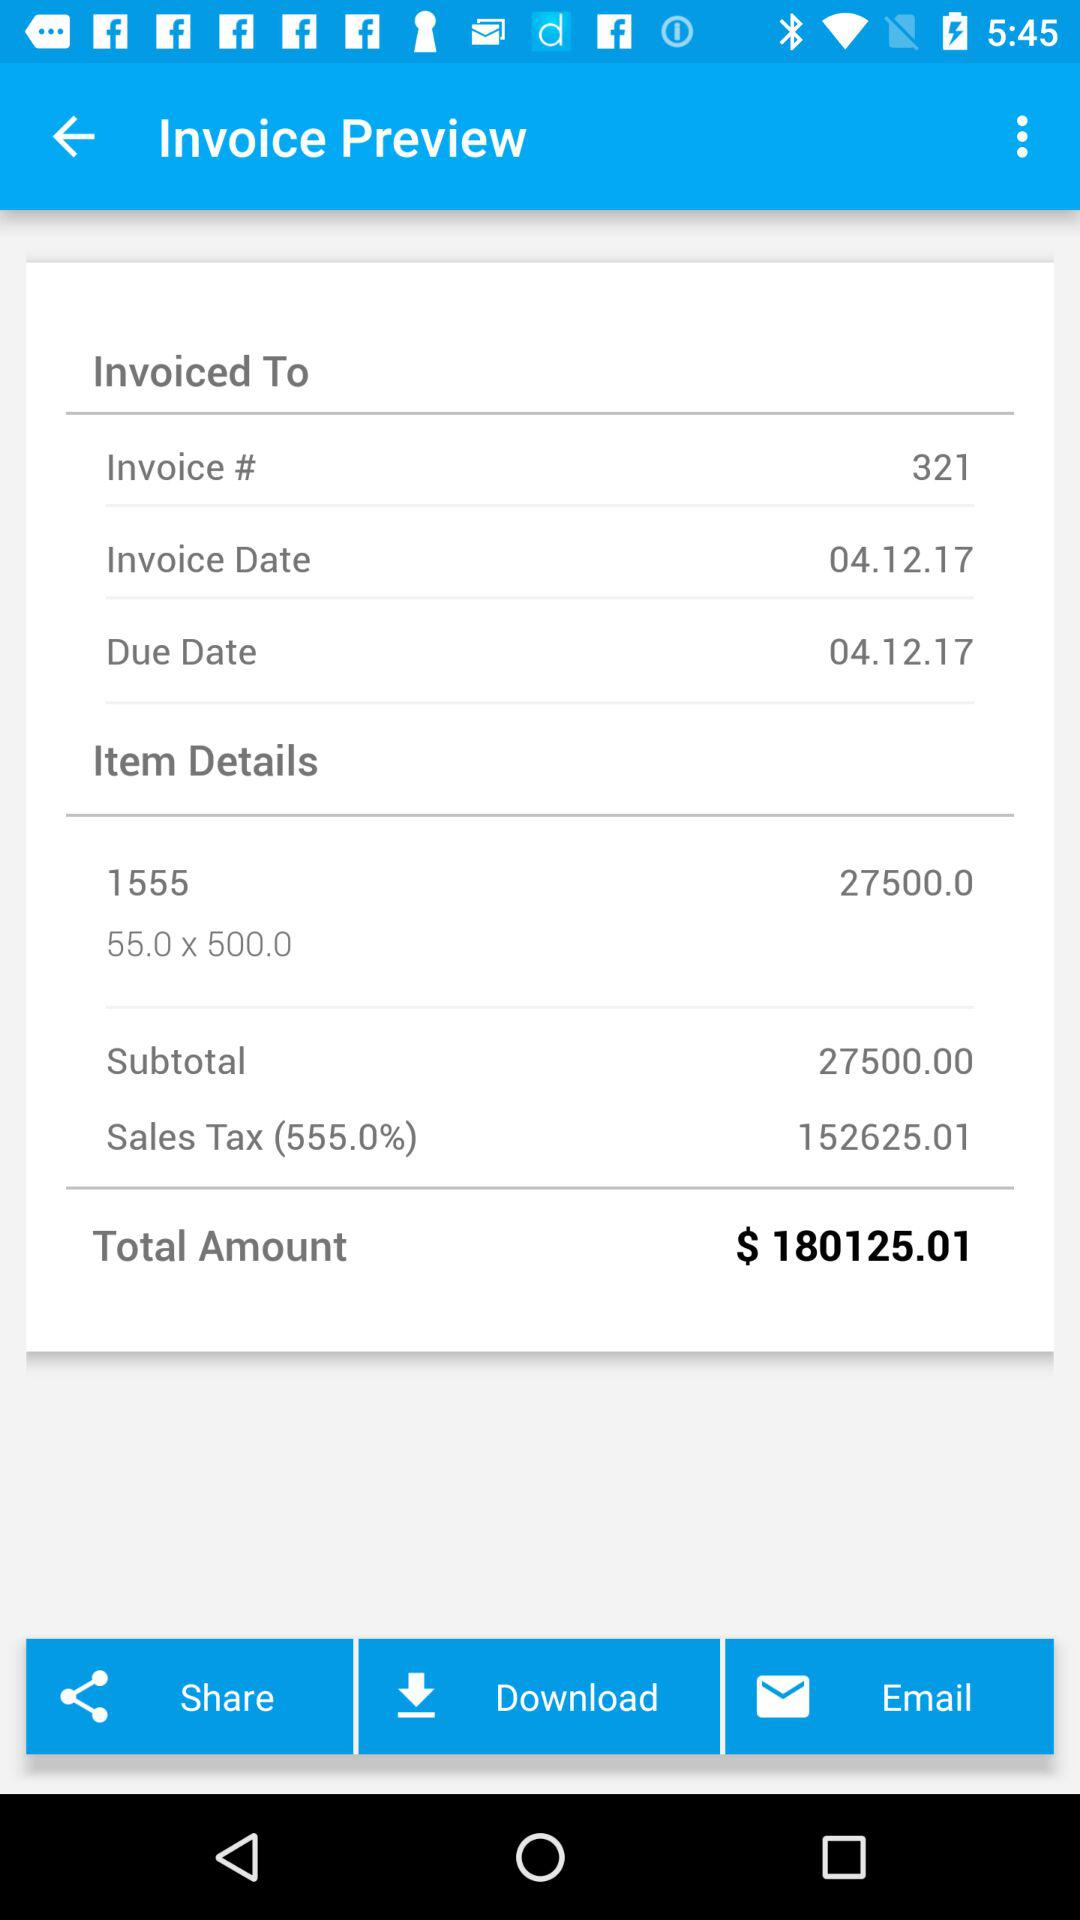What is the sales tax amount? The sales tax amount is 152625.01. 